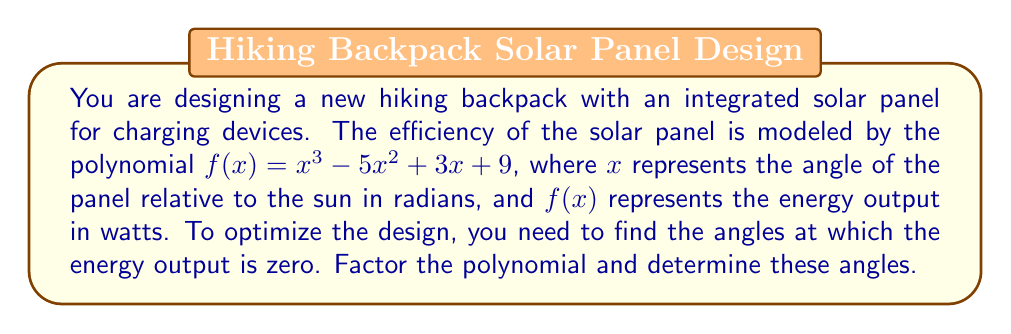Help me with this question. To solve this problem, we need to factor the polynomial $f(x) = x^3 - 5x^2 + 3x + 9$ and find its roots. These roots will represent the angles at which the energy output is zero.

Step 1: Identify if there's a common factor
There is no common factor for all terms, so we proceed to the next step.

Step 2: Check if it's a perfect cube
This polynomial is not a perfect cube, so we move on.

Step 3: Try to factor by grouping
$f(x) = x^3 - 5x^2 + 3x + 9$
$= x^2(x - 5) + 3(x + 3)$
$= x^2(x - 5) + 3(x + 3)$
This doesn't lead to a complete factorization, so we need to try another method.

Step 4: Use the rational root theorem
Possible rational roots are the factors of the constant term (9): $\pm 1, \pm 3, \pm 9$

Testing these values, we find that $x = -3$ is a root.

Step 5: Factor out $(x + 3)$
$f(x) = (x + 3)(x^2 - 8x + 3)$

Step 6: Factor the quadratic term
The quadratic formula gives us the roots of $x^2 - 8x + 3 = 0$:

$x = \frac{8 \pm \sqrt{64 - 12}}{2} = \frac{8 \pm \sqrt{52}}{2} = 4 \pm \sqrt{13}$

Therefore, the complete factorization is:

$f(x) = (x + 3)(x - (4 + \sqrt{13}))(x - (4 - \sqrt{13}))$

The roots of the polynomial, which represent the angles at which the energy output is zero, are:
$x = -3$, $x = 4 + \sqrt{13}$, and $x = 4 - \sqrt{13}$
Answer: The angles at which the energy output is zero are $x = -3$ radians, $x = 4 + \sqrt{13}$ radians, and $x = 4 - \sqrt{13}$ radians. 